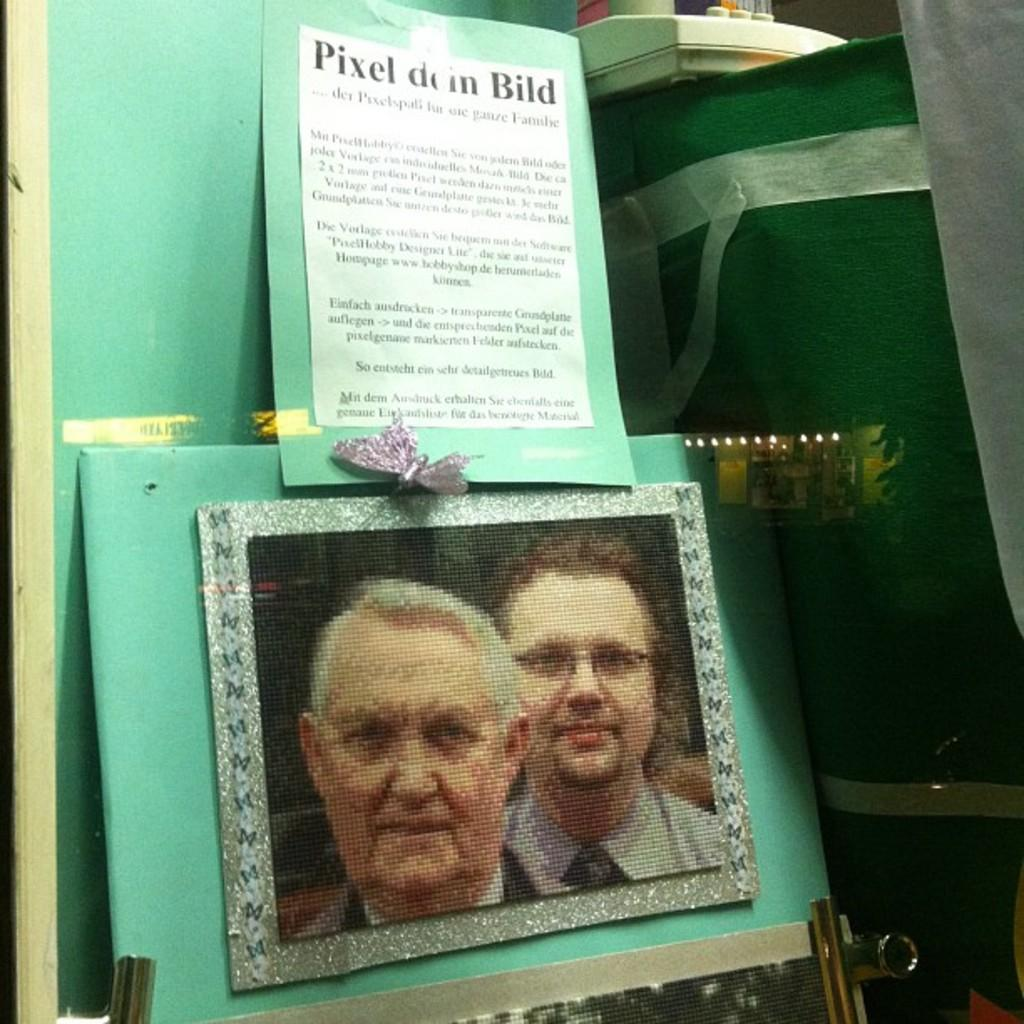What object in the image is typically used for displaying photos? There is a photo frame in the image. What object in the image is commonly used for carrying items? There is a bag in the image. What object in the image is typically used for writing or drawing? There is a board in the image. What material is present in the image that can be used for various purposes, such as clothing or upholstery? There is cloth in the image. What type of object in the image is often used for recording information or creating art? There is paper in the image. What color is the object in the image that is mentioned as being white? There is a white color object in the image. How does the tail of the animal in the image help it move? There is no animal with a tail present in the image. What type of memory is stored in the photo frame in the image? The photo frame in the image is not capable of storing memory; it is used for displaying photos. How does the steam in the image affect the objects around it? There is no steam present in the image. 